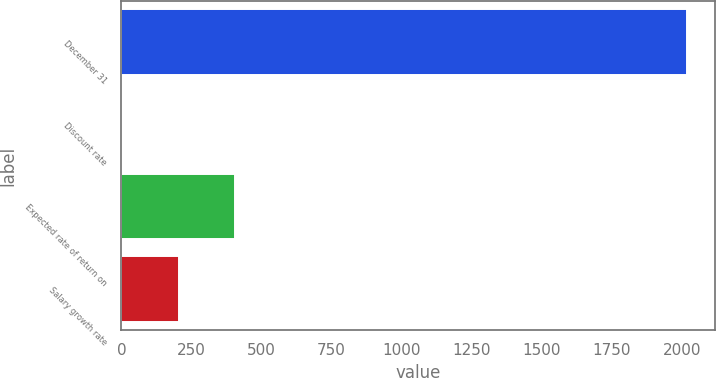<chart> <loc_0><loc_0><loc_500><loc_500><bar_chart><fcel>December 31<fcel>Discount rate<fcel>Expected rate of return on<fcel>Salary growth rate<nl><fcel>2017<fcel>2.2<fcel>405.16<fcel>203.68<nl></chart> 